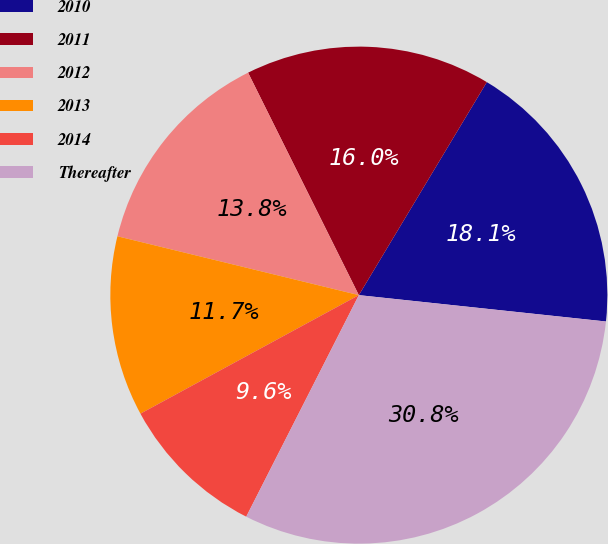Convert chart. <chart><loc_0><loc_0><loc_500><loc_500><pie_chart><fcel>2010<fcel>2011<fcel>2012<fcel>2013<fcel>2014<fcel>Thereafter<nl><fcel>18.08%<fcel>15.96%<fcel>13.84%<fcel>11.72%<fcel>9.6%<fcel>30.79%<nl></chart> 